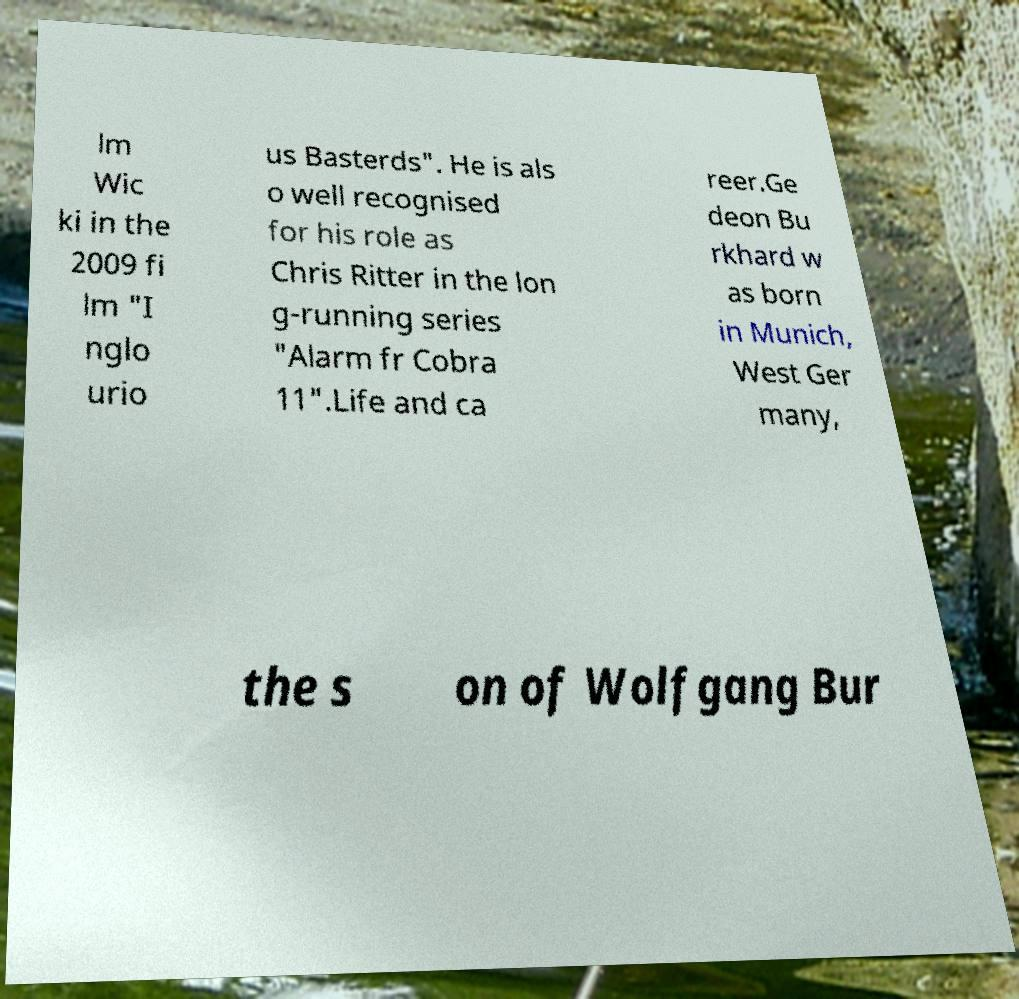I need the written content from this picture converted into text. Can you do that? lm Wic ki in the 2009 fi lm "I nglo urio us Basterds". He is als o well recognised for his role as Chris Ritter in the lon g-running series "Alarm fr Cobra 11".Life and ca reer.Ge deon Bu rkhard w as born in Munich, West Ger many, the s on of Wolfgang Bur 